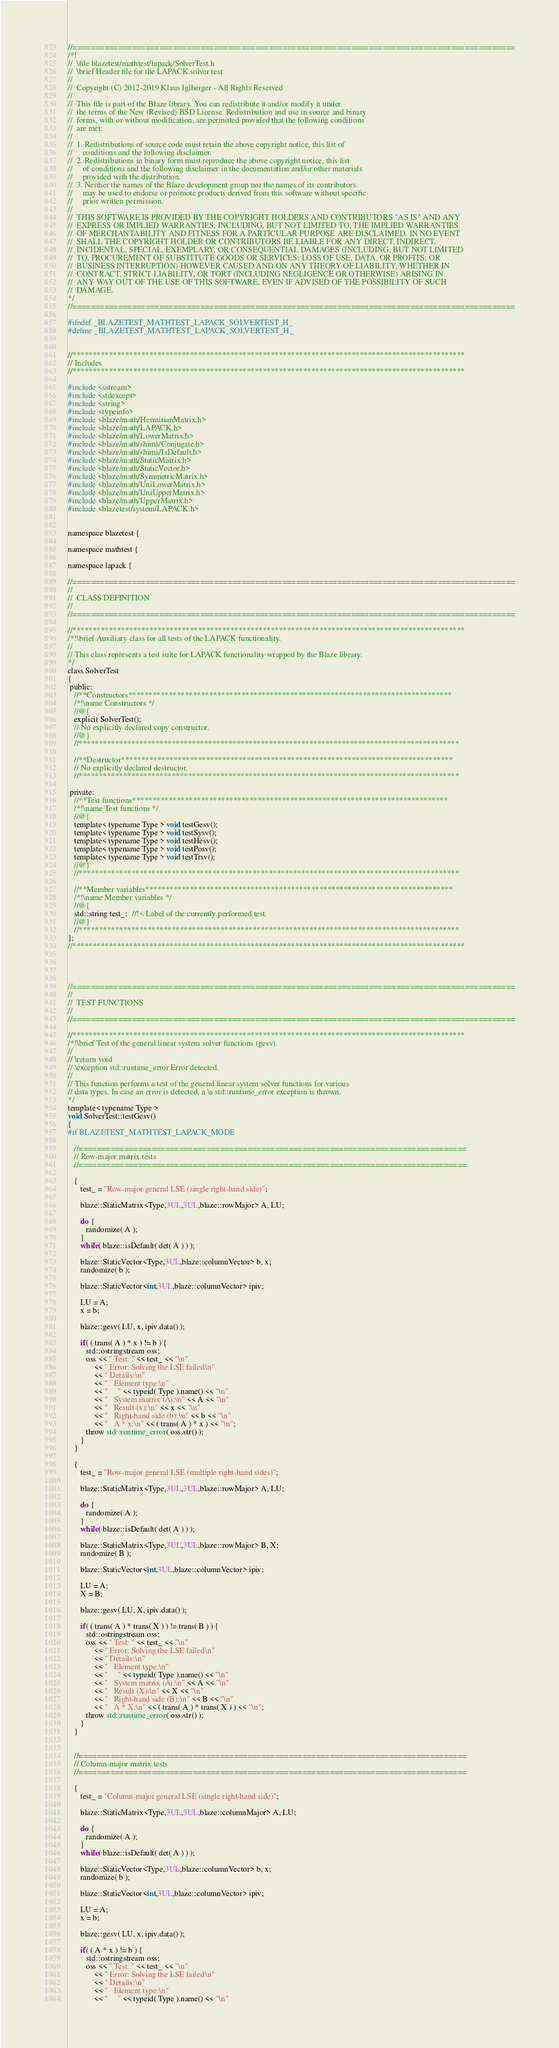Convert code to text. <code><loc_0><loc_0><loc_500><loc_500><_C_>//=================================================================================================
/*!
//  \file blazetest/mathtest/lapack/SolverTest.h
//  \brief Header file for the LAPACK solver test
//
//  Copyright (C) 2012-2019 Klaus Iglberger - All Rights Reserved
//
//  This file is part of the Blaze library. You can redistribute it and/or modify it under
//  the terms of the New (Revised) BSD License. Redistribution and use in source and binary
//  forms, with or without modification, are permitted provided that the following conditions
//  are met:
//
//  1. Redistributions of source code must retain the above copyright notice, this list of
//     conditions and the following disclaimer.
//  2. Redistributions in binary form must reproduce the above copyright notice, this list
//     of conditions and the following disclaimer in the documentation and/or other materials
//     provided with the distribution.
//  3. Neither the names of the Blaze development group nor the names of its contributors
//     may be used to endorse or promote products derived from this software without specific
//     prior written permission.
//
//  THIS SOFTWARE IS PROVIDED BY THE COPYRIGHT HOLDERS AND CONTRIBUTORS "AS IS" AND ANY
//  EXPRESS OR IMPLIED WARRANTIES, INCLUDING, BUT NOT LIMITED TO, THE IMPLIED WARRANTIES
//  OF MERCHANTABILITY AND FITNESS FOR A PARTICULAR PURPOSE ARE DISCLAIMED. IN NO EVENT
//  SHALL THE COPYRIGHT HOLDER OR CONTRIBUTORS BE LIABLE FOR ANY DIRECT, INDIRECT,
//  INCIDENTAL, SPECIAL, EXEMPLARY, OR CONSEQUENTIAL DAMAGES (INCLUDING, BUT NOT LIMITED
//  TO, PROCUREMENT OF SUBSTITUTE GOODS OR SERVICES; LOSS OF USE, DATA, OR PROFITS; OR
//  BUSINESS INTERRUPTION) HOWEVER CAUSED AND ON ANY THEORY OF LIABILITY, WHETHER IN
//  CONTRACT, STRICT LIABILITY, OR TORT (INCLUDING NEGLIGENCE OR OTHERWISE) ARISING IN
//  ANY WAY OUT OF THE USE OF THIS SOFTWARE, EVEN IF ADVISED OF THE POSSIBILITY OF SUCH
//  DAMAGE.
*/
//=================================================================================================

#ifndef _BLAZETEST_MATHTEST_LAPACK_SOLVERTEST_H_
#define _BLAZETEST_MATHTEST_LAPACK_SOLVERTEST_H_


//*************************************************************************************************
// Includes
//*************************************************************************************************

#include <sstream>
#include <stdexcept>
#include <string>
#include <typeinfo>
#include <blaze/math/HermitianMatrix.h>
#include <blaze/math/LAPACK.h>
#include <blaze/math/LowerMatrix.h>
#include <blaze/math/shims/Conjugate.h>
#include <blaze/math/shims/IsDefault.h>
#include <blaze/math/StaticMatrix.h>
#include <blaze/math/StaticVector.h>
#include <blaze/math/SymmetricMatrix.h>
#include <blaze/math/UniLowerMatrix.h>
#include <blaze/math/UniUpperMatrix.h>
#include <blaze/math/UpperMatrix.h>
#include <blazetest/system/LAPACK.h>


namespace blazetest {

namespace mathtest {

namespace lapack {

//=================================================================================================
//
//  CLASS DEFINITION
//
//=================================================================================================

//*************************************************************************************************
/*!\brief Auxiliary class for all tests of the LAPACK functionality.
//
// This class represents a test suite for LAPACK functionality wrapped by the Blaze library.
*/
class SolverTest
{
 public:
   //**Constructors********************************************************************************
   /*!\name Constructors */
   //@{
   explicit SolverTest();
   // No explicitly declared copy constructor.
   //@}
   //**********************************************************************************************

   //**Destructor**********************************************************************************
   // No explicitly declared destructor.
   //**********************************************************************************************

 private:
   //**Test functions******************************************************************************
   /*!\name Test functions */
   //@{
   template< typename Type > void testGesv();
   template< typename Type > void testSysv();
   template< typename Type > void testHesv();
   template< typename Type > void testPosv();
   template< typename Type > void testTrsv();
   //@}
   //**********************************************************************************************

   //**Member variables****************************************************************************
   /*!\name Member variables */
   //@{
   std::string test_;  //!< Label of the currently performed test.
   //@}
   //**********************************************************************************************
};
//*************************************************************************************************




//=================================================================================================
//
//  TEST FUNCTIONS
//
//=================================================================================================

//*************************************************************************************************
/*!\brief Test of the general linear system solver functions (gesv).
//
// \return void
// \exception std::runtime_error Error detected.
//
// This function performs a test of the general linear system solver functions for various
// data types. In case an error is detected, a \a std::runtime_error exception is thrown.
*/
template< typename Type >
void SolverTest::testGesv()
{
#if BLAZETEST_MATHTEST_LAPACK_MODE

   //=====================================================================================
   // Row-major matrix tests
   //=====================================================================================

   {
      test_ = "Row-major general LSE (single right-hand side)";

      blaze::StaticMatrix<Type,3UL,3UL,blaze::rowMajor> A, LU;

      do {
         randomize( A );
      }
      while( blaze::isDefault( det( A ) ) );

      blaze::StaticVector<Type,3UL,blaze::columnVector> b, x;
      randomize( b );

      blaze::StaticVector<int,3UL,blaze::columnVector> ipiv;

      LU = A;
      x = b;

      blaze::gesv( LU, x, ipiv.data() );

      if( ( trans( A ) * x ) != b ) {
         std::ostringstream oss;
         oss << " Test: " << test_ << "\n"
             << " Error: Solving the LSE failed\n"
             << " Details:\n"
             << "   Element type:\n"
             << "     " << typeid( Type ).name() << "\n"
             << "   System matrix (A):\n" << A << "\n"
             << "   Result (x):\n" << x << "\n"
             << "   Right-hand side (b):\n" << b << "\n"
             << "   A * x:\n" << ( trans( A ) * x ) << "\n";
         throw std::runtime_error( oss.str() );
      }
   }

   {
      test_ = "Row-major general LSE (multiple right-hand sides)";

      blaze::StaticMatrix<Type,3UL,3UL,blaze::rowMajor> A, LU;

      do {
         randomize( A );
      }
      while( blaze::isDefault( det( A ) ) );

      blaze::StaticMatrix<Type,3UL,3UL,blaze::rowMajor> B, X;
      randomize( B );

      blaze::StaticVector<int,3UL,blaze::columnVector> ipiv;

      LU = A;
      X = B;

      blaze::gesv( LU, X, ipiv.data() );

      if( ( trans( A ) * trans( X ) ) != trans( B ) ) {
         std::ostringstream oss;
         oss << " Test: " << test_ << "\n"
             << " Error: Solving the LSE failed\n"
             << " Details:\n"
             << "   Element type:\n"
             << "     " << typeid( Type ).name() << "\n"
             << "   System matrix (A):\n" << A << "\n"
             << "   Result (X):\n" << X << "\n"
             << "   Right-hand side (B):\n" << B << "\n"
             << "   A * X:\n" << ( trans( A ) * trans( X ) ) << "\n";
         throw std::runtime_error( oss.str() );
      }
   }


   //=====================================================================================
   // Column-major matrix tests
   //=====================================================================================

   {
      test_ = "Column-major general LSE (single right-hand side)";

      blaze::StaticMatrix<Type,3UL,3UL,blaze::columnMajor> A, LU;

      do {
         randomize( A );
      }
      while( blaze::isDefault( det( A ) ) );

      blaze::StaticVector<Type,3UL,blaze::columnVector> b, x;
      randomize( b );

      blaze::StaticVector<int,3UL,blaze::columnVector> ipiv;

      LU = A;
      x = b;

      blaze::gesv( LU, x, ipiv.data() );

      if( ( A * x ) != b ) {
         std::ostringstream oss;
         oss << " Test: " << test_ << "\n"
             << " Error: Solving the LSE failed\n"
             << " Details:\n"
             << "   Element type:\n"
             << "     " << typeid( Type ).name() << "\n"</code> 